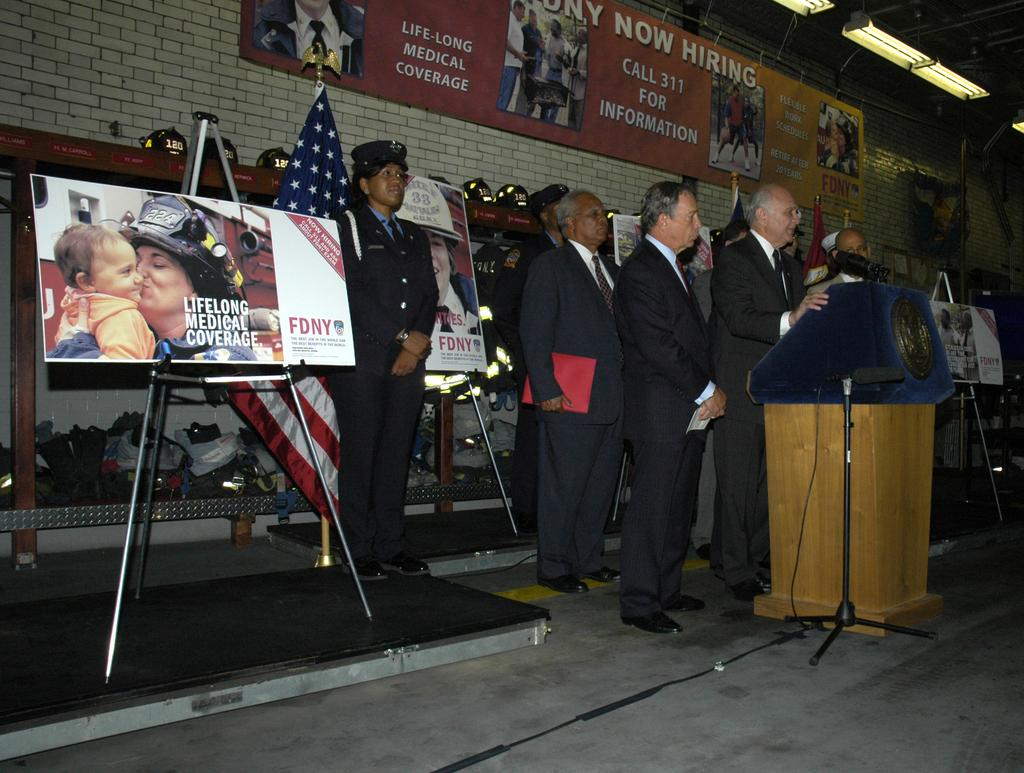What objects are on stands in the image? There are boards on stands in the image. What other items can be seen in the image? There are flags and microphones (mikes) in the image. What is the group of people near in the image? There is a group of people standing near a podium in the image. What is attached to the wall in the image? There are boards attached to the wall in the image. What can be used to illuminate the area in the image? There are lights in the image. What type of stretch is being performed by the group of people in the image? There is no stretch being performed by the group of people in the image; they are standing near a podium. What kind of apparatus is being used by the people in the image? There is no apparatus being used by the people in the image; they are standing near a podium. 